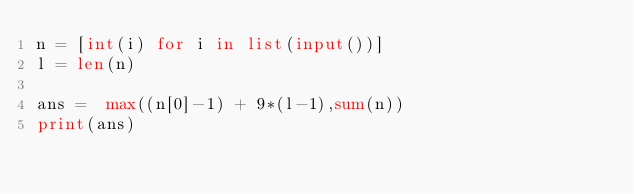Convert code to text. <code><loc_0><loc_0><loc_500><loc_500><_Python_>n = [int(i) for i in list(input())]
l = len(n)

ans =  max((n[0]-1) + 9*(l-1),sum(n))
print(ans)</code> 